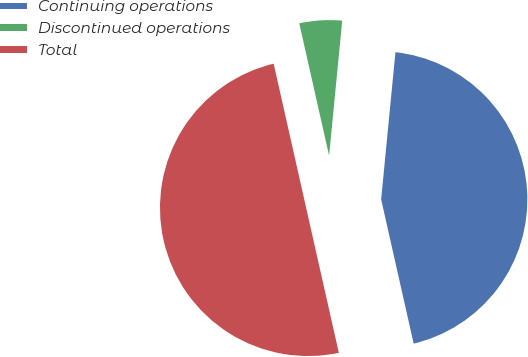Convert chart. <chart><loc_0><loc_0><loc_500><loc_500><pie_chart><fcel>Continuing operations<fcel>Discontinued operations<fcel>Total<nl><fcel>44.93%<fcel>5.07%<fcel>50.0%<nl></chart> 